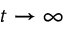<formula> <loc_0><loc_0><loc_500><loc_500>t \rightarrow \infty</formula> 